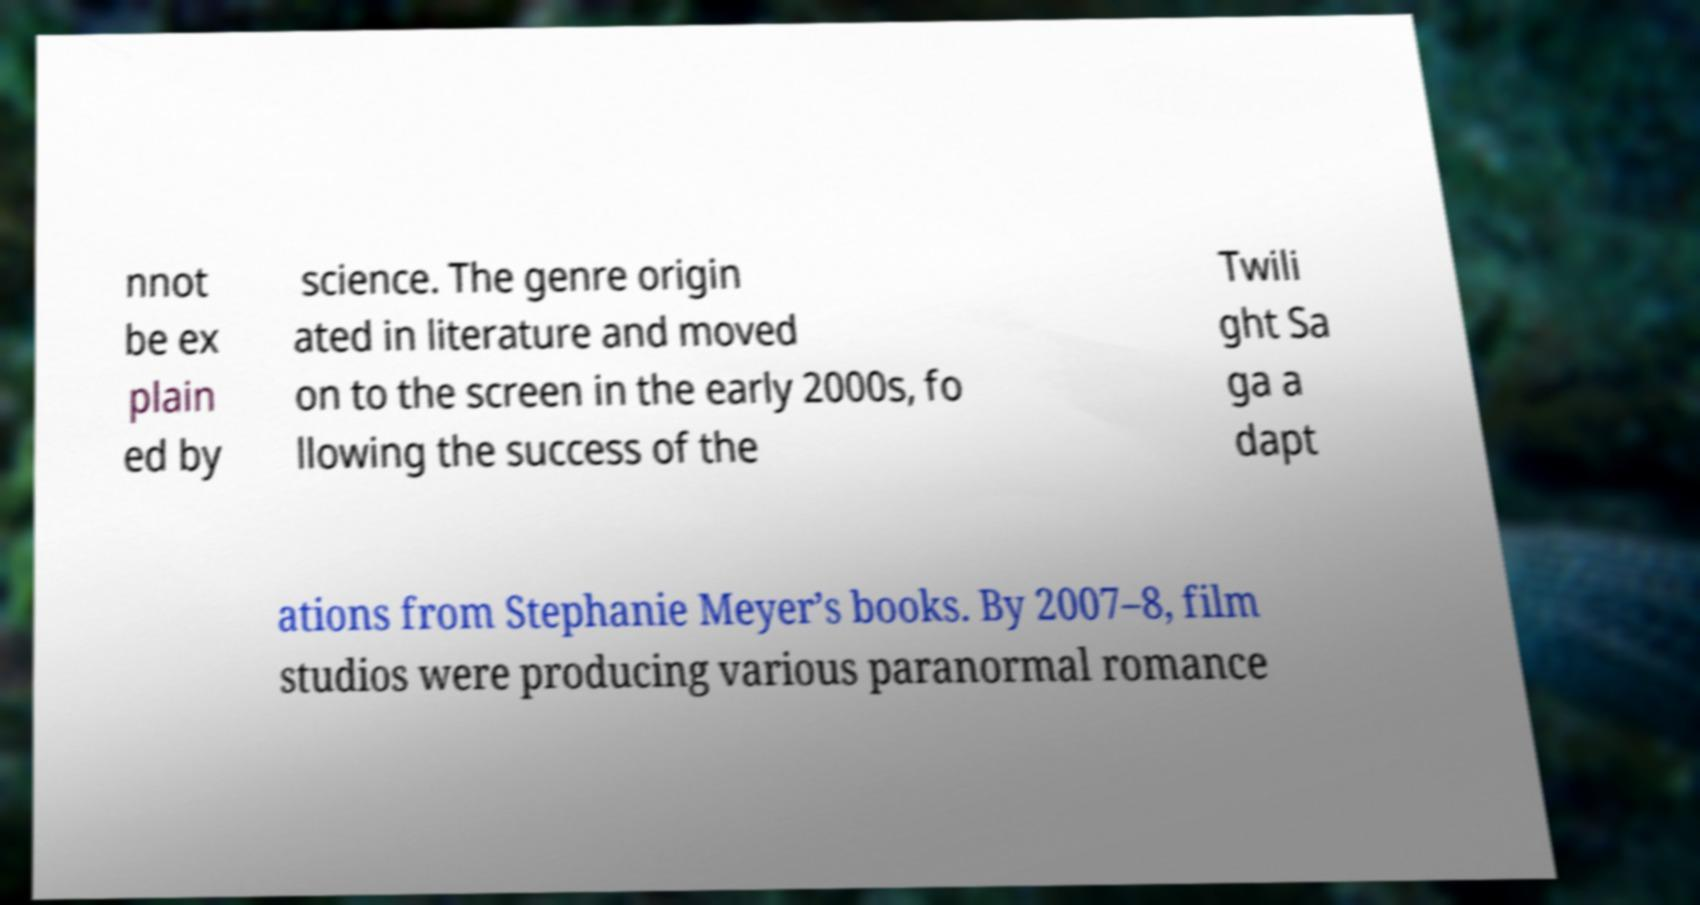What messages or text are displayed in this image? I need them in a readable, typed format. nnot be ex plain ed by science. The genre origin ated in literature and moved on to the screen in the early 2000s, fo llowing the success of the Twili ght Sa ga a dapt ations from Stephanie Meyer’s books. By 2007–8, film studios were producing various paranormal romance 